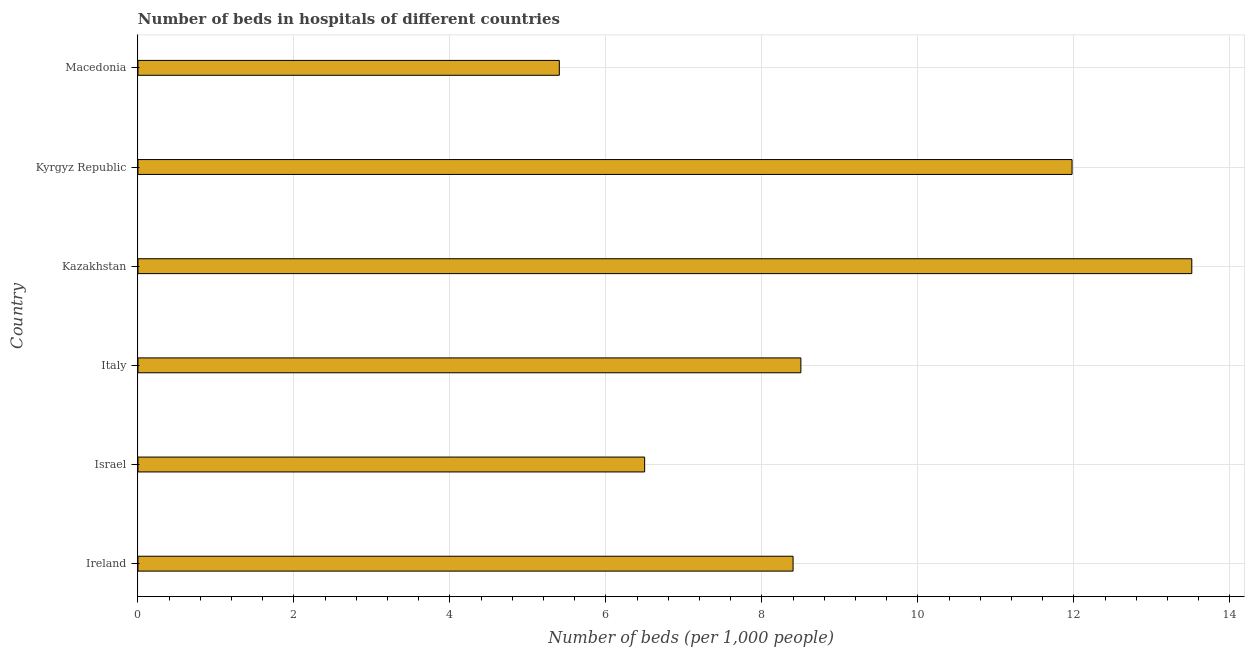Does the graph contain any zero values?
Your response must be concise. No. What is the title of the graph?
Provide a succinct answer. Number of beds in hospitals of different countries. What is the label or title of the X-axis?
Your response must be concise. Number of beds (per 1,0 people). What is the label or title of the Y-axis?
Your response must be concise. Country. What is the number of hospital beds in Israel?
Ensure brevity in your answer.  6.5. Across all countries, what is the maximum number of hospital beds?
Keep it short and to the point. 13.51. Across all countries, what is the minimum number of hospital beds?
Provide a succinct answer. 5.4. In which country was the number of hospital beds maximum?
Provide a short and direct response. Kazakhstan. In which country was the number of hospital beds minimum?
Your response must be concise. Macedonia. What is the sum of the number of hospital beds?
Your response must be concise. 54.29. What is the difference between the number of hospital beds in Israel and Kyrgyz Republic?
Make the answer very short. -5.48. What is the average number of hospital beds per country?
Your response must be concise. 9.05. What is the median number of hospital beds?
Offer a terse response. 8.45. What is the ratio of the number of hospital beds in Israel to that in Macedonia?
Your answer should be compact. 1.2. What is the difference between the highest and the second highest number of hospital beds?
Keep it short and to the point. 1.53. Is the sum of the number of hospital beds in Kazakhstan and Macedonia greater than the maximum number of hospital beds across all countries?
Your answer should be compact. Yes. What is the difference between the highest and the lowest number of hospital beds?
Your response must be concise. 8.11. In how many countries, is the number of hospital beds greater than the average number of hospital beds taken over all countries?
Offer a very short reply. 2. How many countries are there in the graph?
Offer a terse response. 6. Are the values on the major ticks of X-axis written in scientific E-notation?
Ensure brevity in your answer.  No. What is the Number of beds (per 1,000 people) of Ireland?
Provide a succinct answer. 8.4. What is the Number of beds (per 1,000 people) of Israel?
Your response must be concise. 6.5. What is the Number of beds (per 1,000 people) of Kazakhstan?
Provide a short and direct response. 13.51. What is the Number of beds (per 1,000 people) of Kyrgyz Republic?
Give a very brief answer. 11.98. What is the Number of beds (per 1,000 people) of Macedonia?
Ensure brevity in your answer.  5.4. What is the difference between the Number of beds (per 1,000 people) in Ireland and Israel?
Offer a very short reply. 1.9. What is the difference between the Number of beds (per 1,000 people) in Ireland and Kazakhstan?
Ensure brevity in your answer.  -5.11. What is the difference between the Number of beds (per 1,000 people) in Ireland and Kyrgyz Republic?
Your answer should be compact. -3.58. What is the difference between the Number of beds (per 1,000 people) in Ireland and Macedonia?
Offer a terse response. 3. What is the difference between the Number of beds (per 1,000 people) in Israel and Italy?
Your response must be concise. -2. What is the difference between the Number of beds (per 1,000 people) in Israel and Kazakhstan?
Give a very brief answer. -7.02. What is the difference between the Number of beds (per 1,000 people) in Israel and Kyrgyz Republic?
Your answer should be compact. -5.48. What is the difference between the Number of beds (per 1,000 people) in Israel and Macedonia?
Your answer should be compact. 1.09. What is the difference between the Number of beds (per 1,000 people) in Italy and Kazakhstan?
Your response must be concise. -5.01. What is the difference between the Number of beds (per 1,000 people) in Italy and Kyrgyz Republic?
Make the answer very short. -3.48. What is the difference between the Number of beds (per 1,000 people) in Italy and Macedonia?
Your answer should be very brief. 3.1. What is the difference between the Number of beds (per 1,000 people) in Kazakhstan and Kyrgyz Republic?
Your answer should be compact. 1.54. What is the difference between the Number of beds (per 1,000 people) in Kazakhstan and Macedonia?
Give a very brief answer. 8.11. What is the difference between the Number of beds (per 1,000 people) in Kyrgyz Republic and Macedonia?
Provide a short and direct response. 6.57. What is the ratio of the Number of beds (per 1,000 people) in Ireland to that in Israel?
Make the answer very short. 1.29. What is the ratio of the Number of beds (per 1,000 people) in Ireland to that in Italy?
Offer a terse response. 0.99. What is the ratio of the Number of beds (per 1,000 people) in Ireland to that in Kazakhstan?
Provide a short and direct response. 0.62. What is the ratio of the Number of beds (per 1,000 people) in Ireland to that in Kyrgyz Republic?
Your answer should be compact. 0.7. What is the ratio of the Number of beds (per 1,000 people) in Ireland to that in Macedonia?
Offer a very short reply. 1.55. What is the ratio of the Number of beds (per 1,000 people) in Israel to that in Italy?
Your answer should be very brief. 0.76. What is the ratio of the Number of beds (per 1,000 people) in Israel to that in Kazakhstan?
Make the answer very short. 0.48. What is the ratio of the Number of beds (per 1,000 people) in Israel to that in Kyrgyz Republic?
Ensure brevity in your answer.  0.54. What is the ratio of the Number of beds (per 1,000 people) in Israel to that in Macedonia?
Your answer should be compact. 1.2. What is the ratio of the Number of beds (per 1,000 people) in Italy to that in Kazakhstan?
Give a very brief answer. 0.63. What is the ratio of the Number of beds (per 1,000 people) in Italy to that in Kyrgyz Republic?
Provide a short and direct response. 0.71. What is the ratio of the Number of beds (per 1,000 people) in Italy to that in Macedonia?
Keep it short and to the point. 1.57. What is the ratio of the Number of beds (per 1,000 people) in Kazakhstan to that in Kyrgyz Republic?
Make the answer very short. 1.13. What is the ratio of the Number of beds (per 1,000 people) in Kazakhstan to that in Macedonia?
Ensure brevity in your answer.  2.5. What is the ratio of the Number of beds (per 1,000 people) in Kyrgyz Republic to that in Macedonia?
Provide a succinct answer. 2.22. 